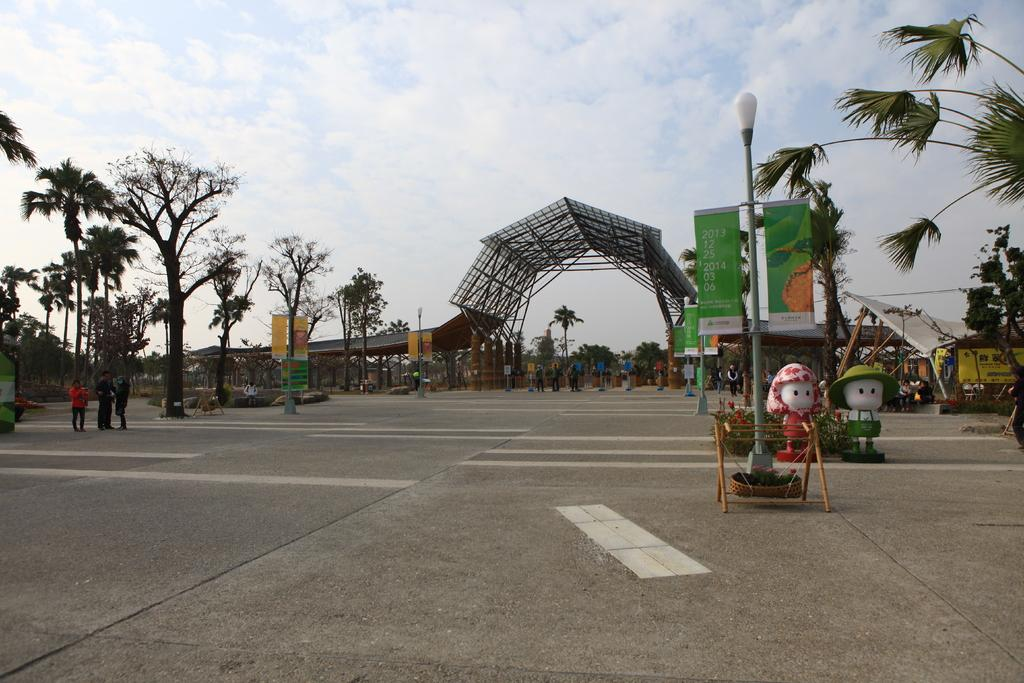What is: What is the main feature of the image? The main feature of the image is a road. Can you describe the people in the image? There are people in the image, but their specific actions or roles are not clear from the facts provided. What is the purpose of the basket in the image? The purpose of the basket in the image is not clear from the facts provided. What type of plants are in the image? The type of plants in the image is not specified in the facts provided. What do the statues represent in the image? The representation of the statues in the image is not clear from the facts provided. What message do the banners convey in the image? The message on the banners in the image is not clear from the facts provided. What is the purpose of the shelter in the image? The purpose of the shelter in the image is not clear from the facts provided. What type of trees are in the image? The type of trees in the image is not specified in the facts provided. What are the various objects in the image? The various objects in the image are not specified in the facts provided. What is the weather like in the image? The weather in the image can be inferred as partly cloudy, as the sky is visible with clouds in the background. Are there any servants attending to the statues in the image? There is no mention of servants or their attendance to the statues in the image. Is there a battle taking place in the image? There is no indication of a battle or any conflict in the image. What type of cord is used to hang the banners in the image? The type of cord used to hang the banners in the image is not specified in the facts provided. 